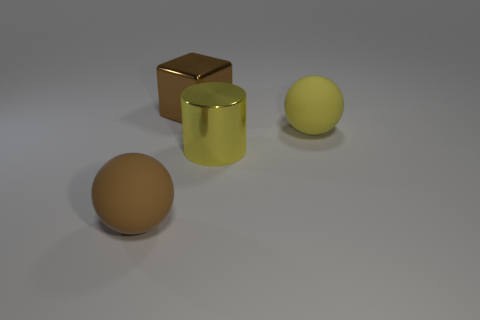Add 2 yellow metal cylinders. How many objects exist? 6 Subtract all cylinders. How many objects are left? 3 Subtract all brown things. Subtract all tiny blue shiny cubes. How many objects are left? 2 Add 1 large rubber objects. How many large rubber objects are left? 3 Add 2 large yellow metal cylinders. How many large yellow metal cylinders exist? 3 Subtract 0 gray cubes. How many objects are left? 4 